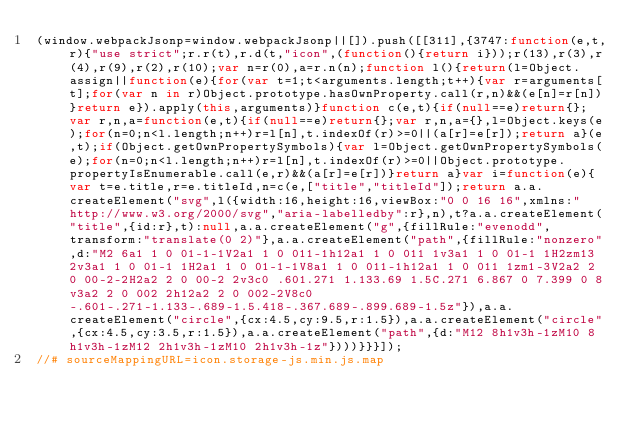<code> <loc_0><loc_0><loc_500><loc_500><_JavaScript_>(window.webpackJsonp=window.webpackJsonp||[]).push([[311],{3747:function(e,t,r){"use strict";r.r(t),r.d(t,"icon",(function(){return i}));r(13),r(3),r(4),r(9),r(2),r(10);var n=r(0),a=r.n(n);function l(){return(l=Object.assign||function(e){for(var t=1;t<arguments.length;t++){var r=arguments[t];for(var n in r)Object.prototype.hasOwnProperty.call(r,n)&&(e[n]=r[n])}return e}).apply(this,arguments)}function c(e,t){if(null==e)return{};var r,n,a=function(e,t){if(null==e)return{};var r,n,a={},l=Object.keys(e);for(n=0;n<l.length;n++)r=l[n],t.indexOf(r)>=0||(a[r]=e[r]);return a}(e,t);if(Object.getOwnPropertySymbols){var l=Object.getOwnPropertySymbols(e);for(n=0;n<l.length;n++)r=l[n],t.indexOf(r)>=0||Object.prototype.propertyIsEnumerable.call(e,r)&&(a[r]=e[r])}return a}var i=function(e){var t=e.title,r=e.titleId,n=c(e,["title","titleId"]);return a.a.createElement("svg",l({width:16,height:16,viewBox:"0 0 16 16",xmlns:"http://www.w3.org/2000/svg","aria-labelledby":r},n),t?a.a.createElement("title",{id:r},t):null,a.a.createElement("g",{fillRule:"evenodd",transform:"translate(0 2)"},a.a.createElement("path",{fillRule:"nonzero",d:"M2 6a1 1 0 01-1-1V2a1 1 0 011-1h12a1 1 0 011 1v3a1 1 0 01-1 1H2zm13 2v3a1 1 0 01-1 1H2a1 1 0 01-1-1V8a1 1 0 011-1h12a1 1 0 011 1zm1-3V2a2 2 0 00-2-2H2a2 2 0 00-2 2v3c0 .601.271 1.133.69 1.5C.271 6.867 0 7.399 0 8v3a2 2 0 002 2h12a2 2 0 002-2V8c0-.601-.271-1.133-.689-1.5.418-.367.689-.899.689-1.5z"}),a.a.createElement("circle",{cx:4.5,cy:9.5,r:1.5}),a.a.createElement("circle",{cx:4.5,cy:3.5,r:1.5}),a.a.createElement("path",{d:"M12 8h1v3h-1zM10 8h1v3h-1zM12 2h1v3h-1zM10 2h1v3h-1z"})))}}}]);
//# sourceMappingURL=icon.storage-js.min.js.map</code> 